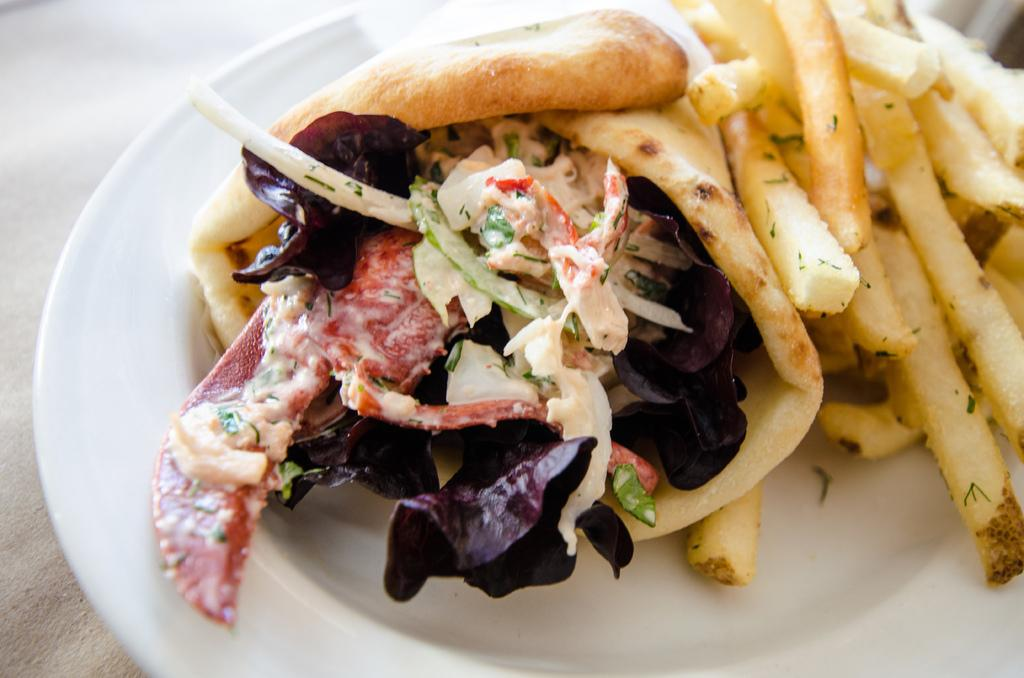What is on the plate that is visible in the image? The plate contains food. Where is the plate located in the image? The plate is placed on a surface. What type of branch can be seen growing out of the plate in the image? There is no branch present in the image; the plate contains food and is placed on a surface. 